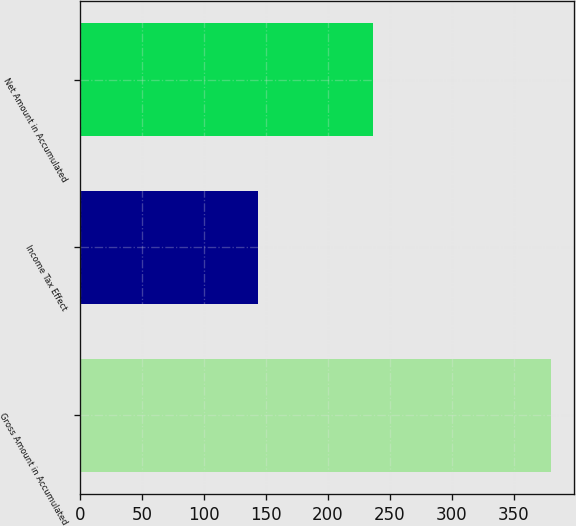<chart> <loc_0><loc_0><loc_500><loc_500><bar_chart><fcel>Gross Amount in Accumulated<fcel>Income Tax Effect<fcel>Net Amount in Accumulated<nl><fcel>379.8<fcel>143.3<fcel>236.5<nl></chart> 